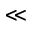Convert formula to latex. <formula><loc_0><loc_0><loc_500><loc_500>\ll</formula> 